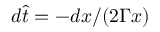<formula> <loc_0><loc_0><loc_500><loc_500>d \hat { t } = - d x / ( 2 \Gamma x )</formula> 